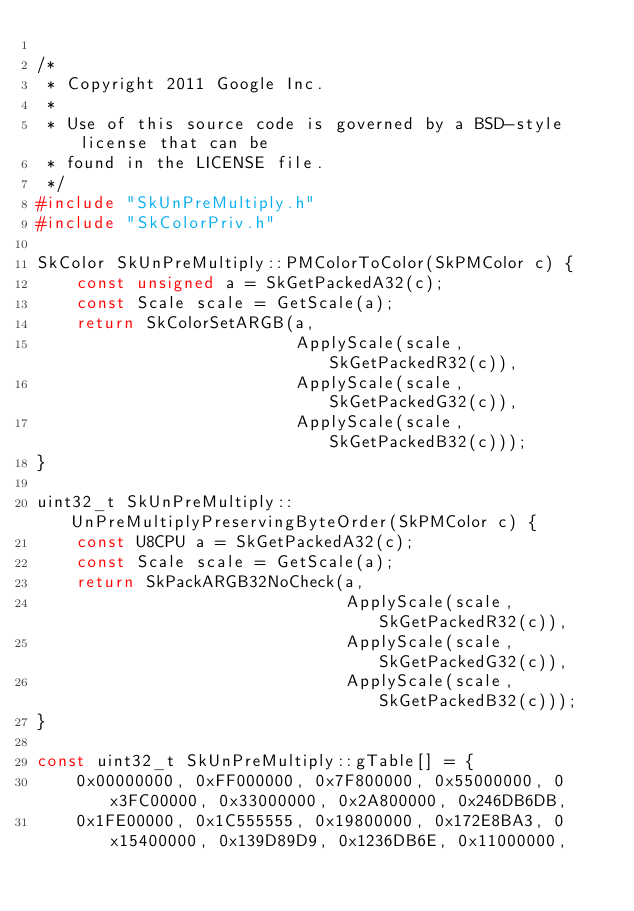<code> <loc_0><loc_0><loc_500><loc_500><_C++_>
/*
 * Copyright 2011 Google Inc.
 *
 * Use of this source code is governed by a BSD-style license that can be
 * found in the LICENSE file.
 */
#include "SkUnPreMultiply.h"
#include "SkColorPriv.h"

SkColor SkUnPreMultiply::PMColorToColor(SkPMColor c) {
    const unsigned a = SkGetPackedA32(c);
    const Scale scale = GetScale(a);
    return SkColorSetARGB(a,
                          ApplyScale(scale, SkGetPackedR32(c)),
                          ApplyScale(scale, SkGetPackedG32(c)),
                          ApplyScale(scale, SkGetPackedB32(c)));
}

uint32_t SkUnPreMultiply::UnPreMultiplyPreservingByteOrder(SkPMColor c) {
    const U8CPU a = SkGetPackedA32(c);
    const Scale scale = GetScale(a);
    return SkPackARGB32NoCheck(a,
                               ApplyScale(scale, SkGetPackedR32(c)),
                               ApplyScale(scale, SkGetPackedG32(c)),
                               ApplyScale(scale, SkGetPackedB32(c)));
}

const uint32_t SkUnPreMultiply::gTable[] = {
    0x00000000, 0xFF000000, 0x7F800000, 0x55000000, 0x3FC00000, 0x33000000, 0x2A800000, 0x246DB6DB,
    0x1FE00000, 0x1C555555, 0x19800000, 0x172E8BA3, 0x15400000, 0x139D89D9, 0x1236DB6E, 0x11000000,</code> 